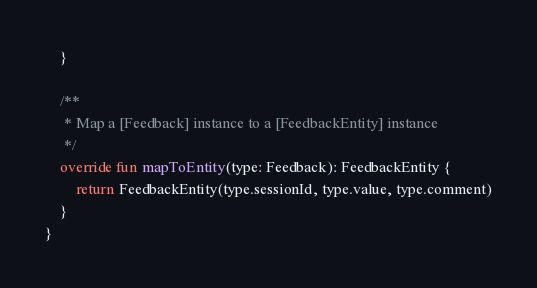<code> <loc_0><loc_0><loc_500><loc_500><_Kotlin_>    }

    /**
     * Map a [Feedback] instance to a [FeedbackEntity] instance
     */
    override fun mapToEntity(type: Feedback): FeedbackEntity {
        return FeedbackEntity(type.sessionId, type.value, type.comment)
    }
}</code> 